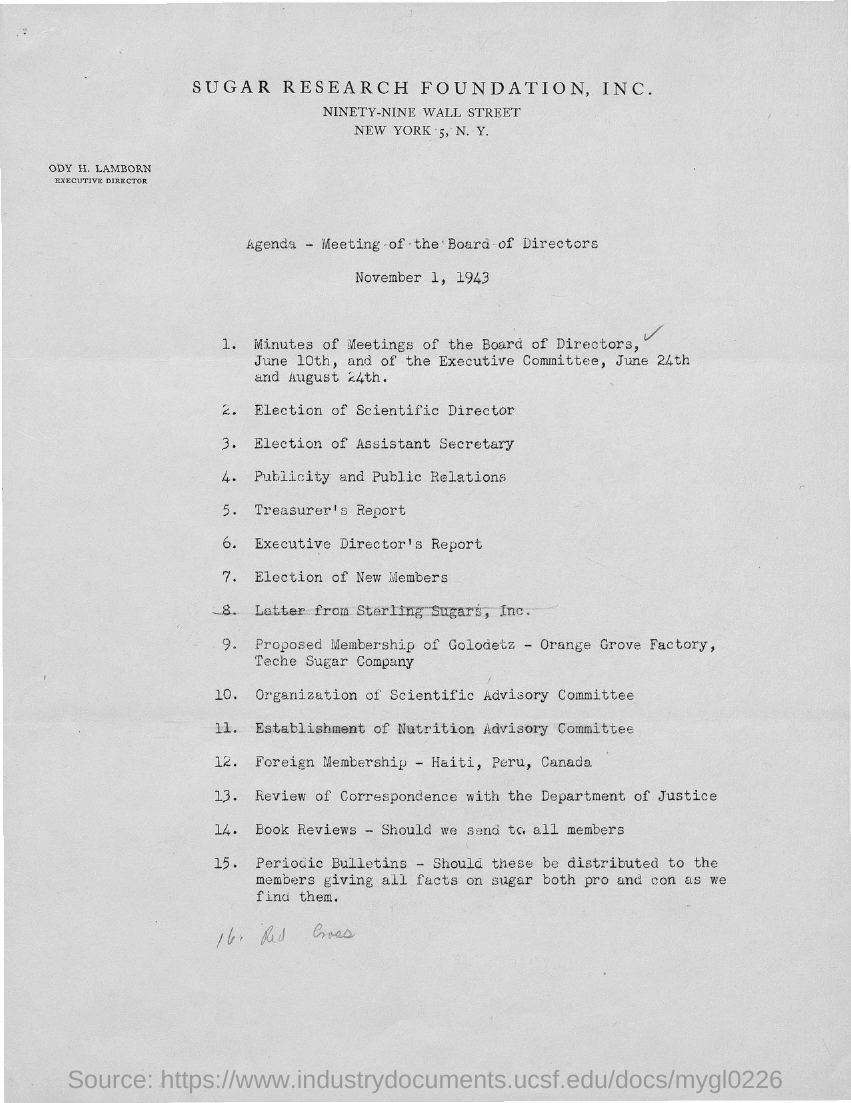Give some essential details in this illustration. Ody H. Lamborn is the executive director. The document mentions SUGAR RESEARCH FOUNDATION, INC. in its header. 